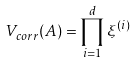<formula> <loc_0><loc_0><loc_500><loc_500>V _ { c o r r } ( { A } ) = \prod _ { i = 1 } ^ { d } \xi ^ { ( i ) }</formula> 